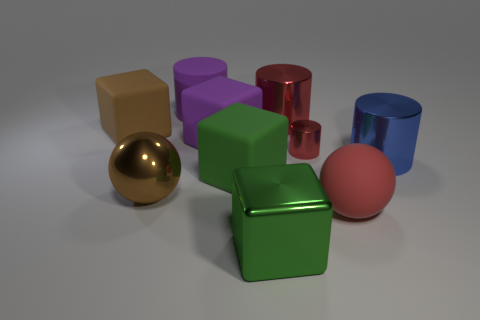Are the blue object and the tiny red cylinder made of the same material?
Your answer should be compact. Yes. What shape is the green thing that is the same material as the brown ball?
Offer a terse response. Cube. Are there fewer big brown blocks than small purple matte balls?
Provide a succinct answer. No. There is a object that is both in front of the large purple cube and on the left side of the purple cylinder; what material is it?
Provide a succinct answer. Metal. What is the size of the red metallic cylinder in front of the brown object that is behind the metallic cylinder that is in front of the small metal thing?
Make the answer very short. Small. There is a tiny red thing; is it the same shape as the big red object that is behind the large green rubber block?
Offer a terse response. Yes. What number of big metallic objects are in front of the tiny metallic cylinder and behind the green metallic object?
Keep it short and to the point. 2. What number of brown objects are tiny metal things or cylinders?
Keep it short and to the point. 0. There is a sphere right of the big green metallic thing; is it the same color as the metal cylinder that is behind the small cylinder?
Offer a very short reply. Yes. There is a sphere that is on the right side of the large sphere left of the big shiny object that is in front of the rubber sphere; what color is it?
Your answer should be very brief. Red. 